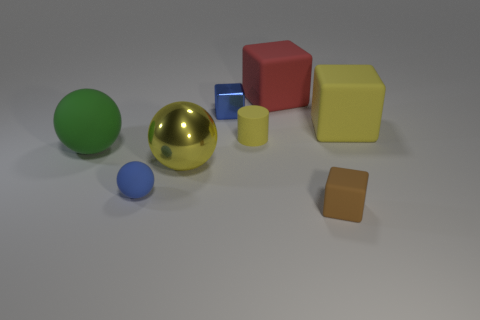Subtract all blue matte balls. How many balls are left? 2 Subtract all blue spheres. How many spheres are left? 2 Add 1 big rubber blocks. How many objects exist? 9 Subtract all balls. How many objects are left? 5 Subtract 3 blocks. How many blocks are left? 1 Subtract all purple metallic spheres. Subtract all small blue metallic blocks. How many objects are left? 7 Add 6 red rubber things. How many red rubber things are left? 7 Add 1 small green metallic blocks. How many small green metallic blocks exist? 1 Subtract 1 yellow cylinders. How many objects are left? 7 Subtract all blue cubes. Subtract all brown cylinders. How many cubes are left? 3 